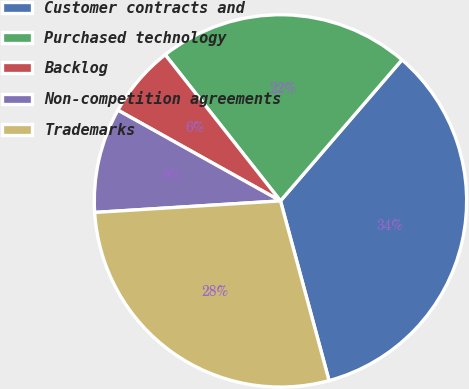Convert chart to OTSL. <chart><loc_0><loc_0><loc_500><loc_500><pie_chart><fcel>Customer contracts and<fcel>Purchased technology<fcel>Backlog<fcel>Non-competition agreements<fcel>Trademarks<nl><fcel>34.48%<fcel>21.94%<fcel>6.27%<fcel>9.09%<fcel>28.21%<nl></chart> 